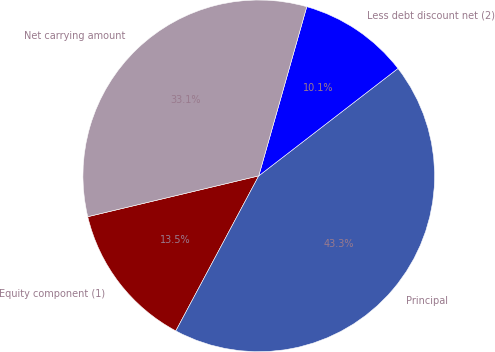Convert chart to OTSL. <chart><loc_0><loc_0><loc_500><loc_500><pie_chart><fcel>Equity component (1)<fcel>Principal<fcel>Less debt discount net (2)<fcel>Net carrying amount<nl><fcel>13.45%<fcel>43.27%<fcel>10.14%<fcel>33.13%<nl></chart> 